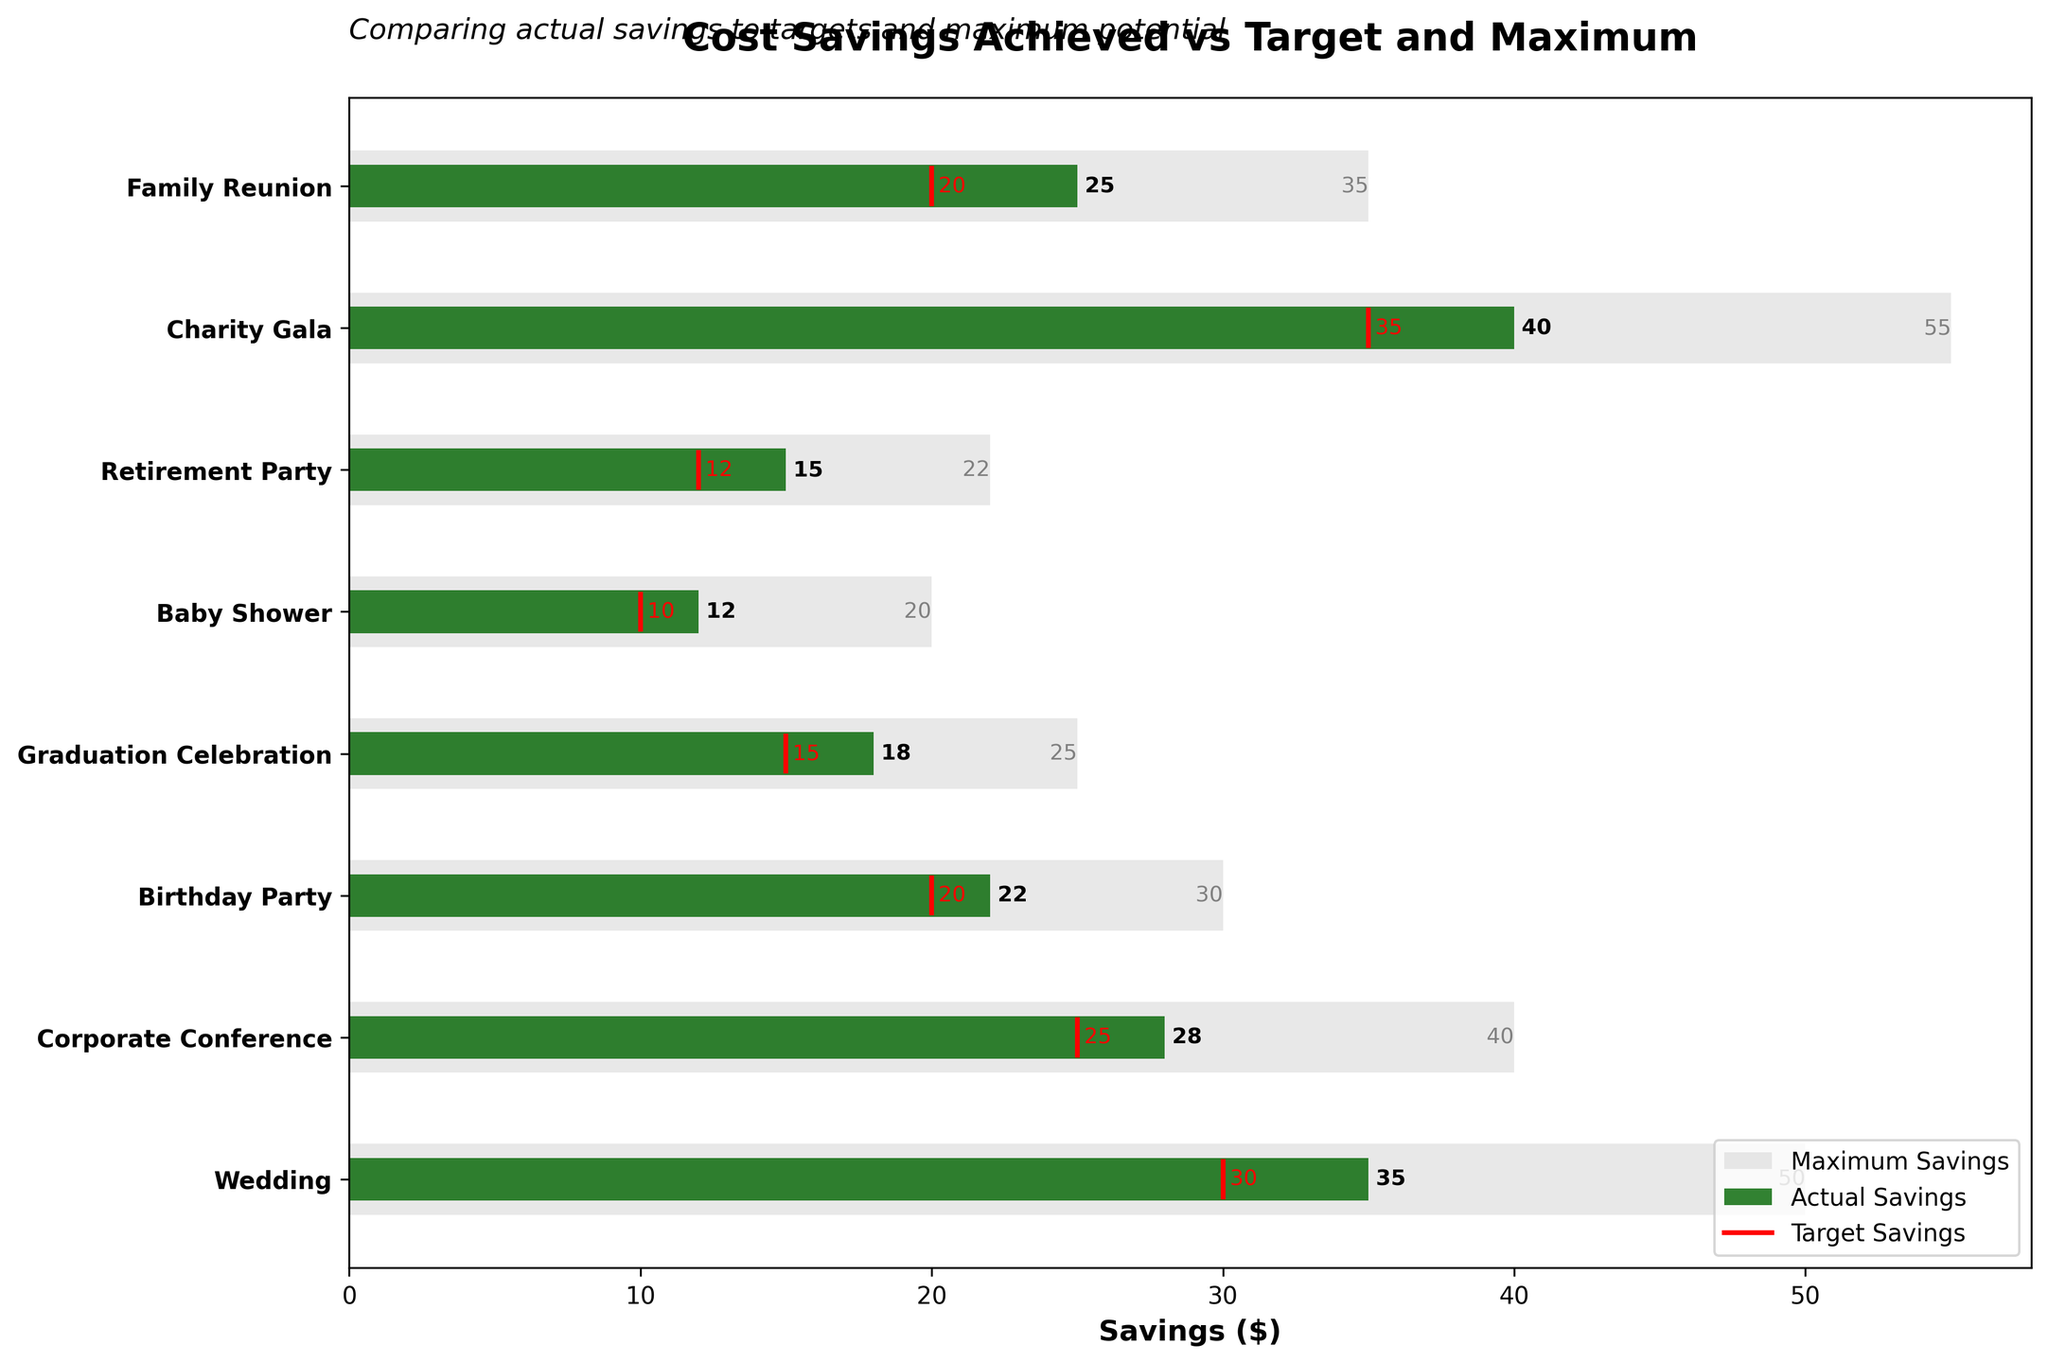How many categories are compared in the plot? Count the number of entries on the y-axis (categories): Wedding, Corporate Conference, Birthday Party, Graduation Celebration, Baby Shower, Retirement Party, Charity Gala, Family Reunion.
Answer: 8 What color represents the maximum savings in the plot? The legend shows that the light grey color represents the maximum savings.
Answer: Light grey Which event achieved the highest actual savings? The bullet chart shows the green bars for actual savings. The Charity Gala has the longest green bar, indicating the highest actual savings.
Answer: Charity Gala How much more did the Charity Gala save compared to its target savings? The actual savings for Charity Gala are 40, and the target savings are 35. Subtract the target savings from the actual savings (40 - 35).
Answer: 5 Which event had the smallest target savings? The red target line with the smallest value corresponds to the Baby Shower, which has a target savings of 10.
Answer: Baby Shower What is the difference between the maximum savings and actual savings for the Family Reunion? The maximum savings for the Family Reunion is 35, and the actual savings is 25. Subtract actual savings from maximum savings (35 - 25).
Answer: 10 Compare the actual savings and target savings for the Wedding. Did it exceed the target, and by how much? The actual savings for the Wedding are 35, and the target savings are 30. Subtract the target savings from the actual savings (35 - 30).
Answer: Yes, by 5 Which event has an actual savings amount closest to its target savings? By visually inspecting the distance between the green bar (actual savings) and the red line (target savings), the Graduation Celebration (18 actual, 15 target) has the smallest difference.
Answer: Graduation Celebration In which event did the actual savings not exceed the target savings? By comparing the green bars (actual savings) to the red lines (target savings), no event where the green bar is shorter. All events exceeded their targets.
Answer: None What is the average actual savings across all events? Add all actual savings: 35 + 28 + 22 + 18 + 12 + 15 + 40 + 25 = 195. The number of events is 8. Divide the sum by the number of events (195 / 8).
Answer: 24.375 